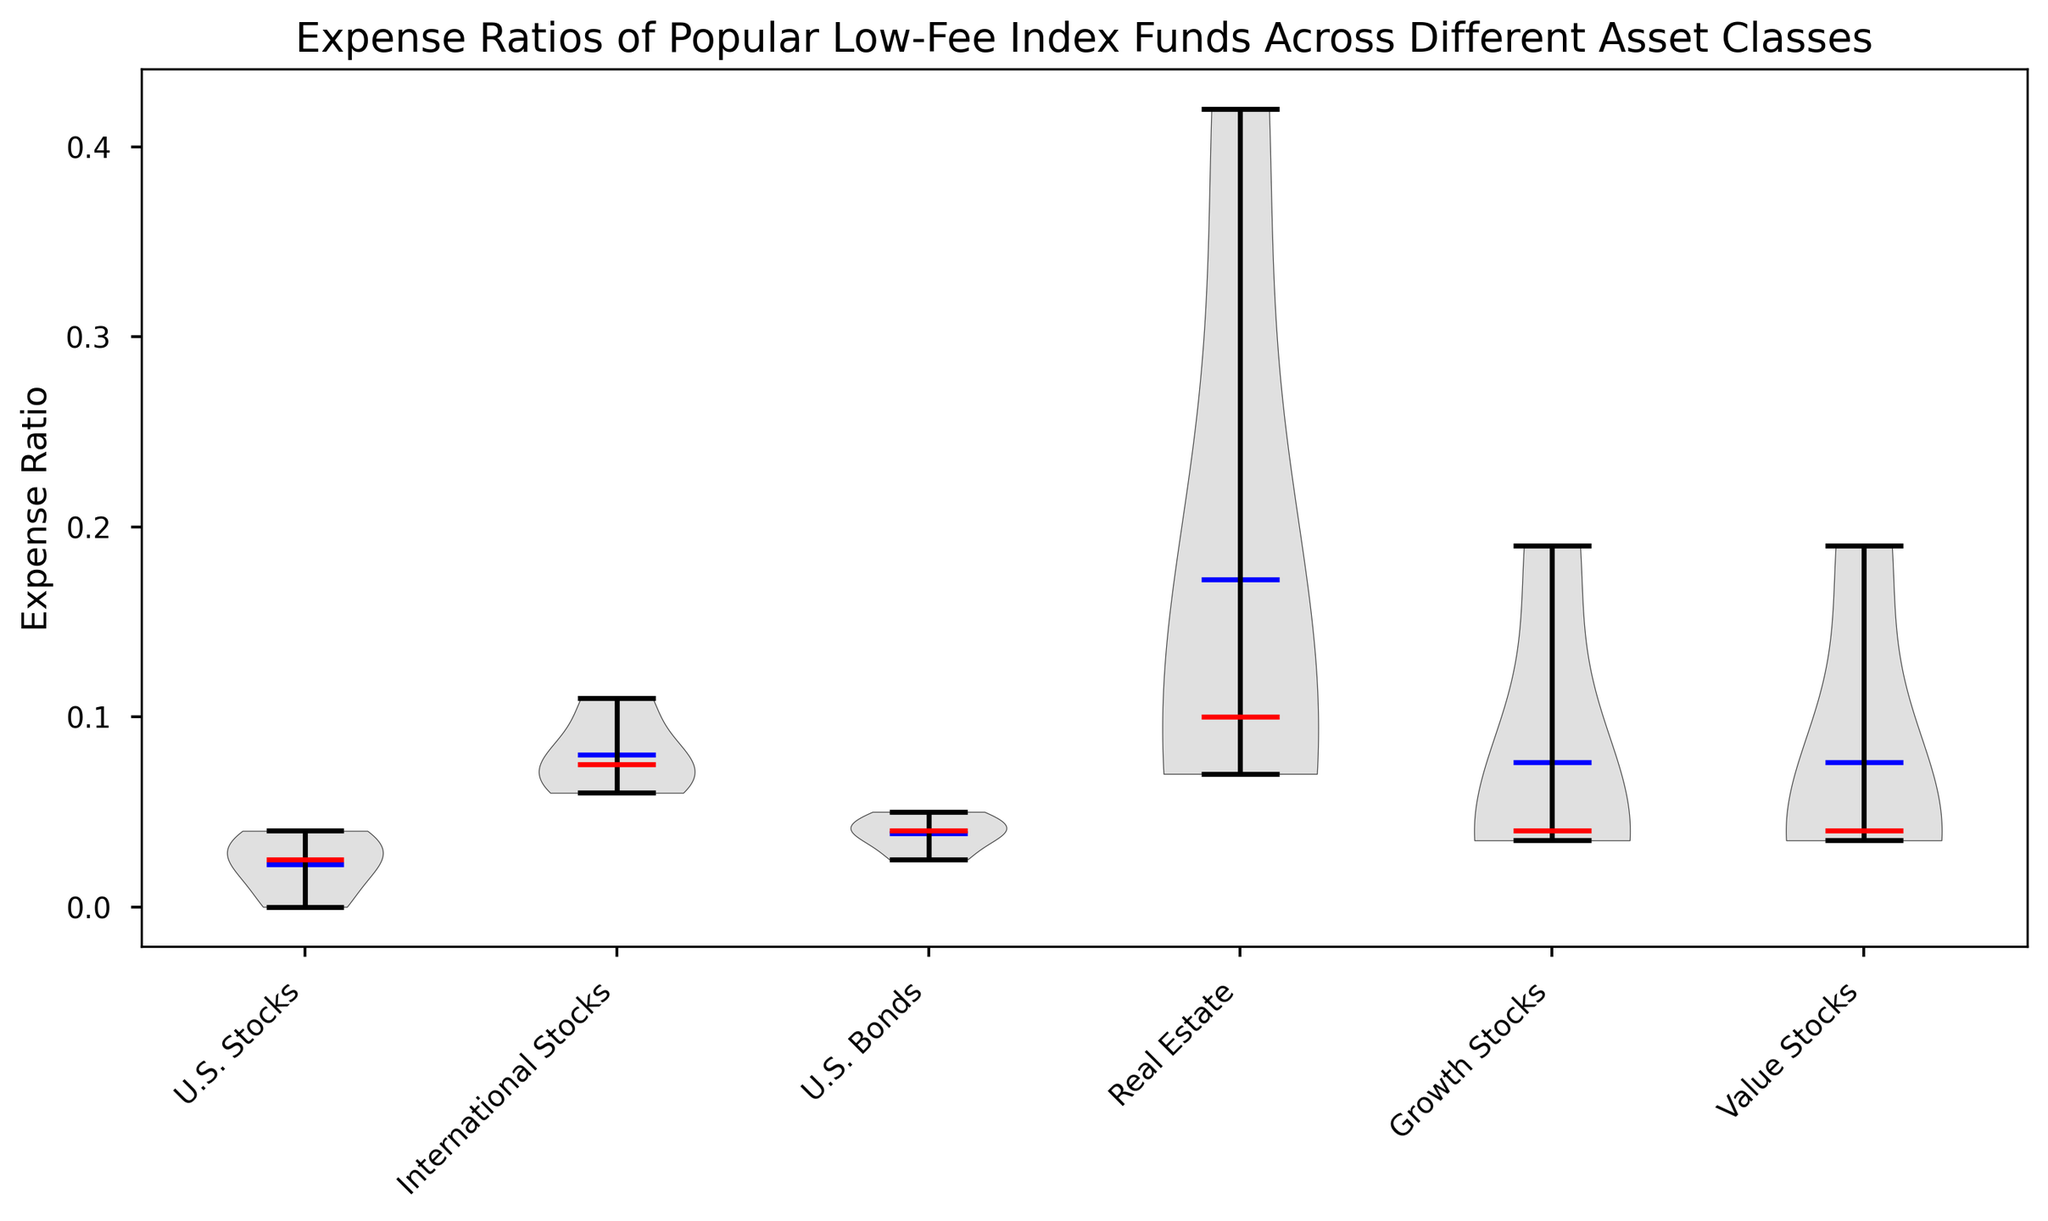What is the range of Expense Ratios for U.S. Stocks funds? The range of Expense Ratios for U.S. Stocks funds can be determined by observing the highest and lowest points of the U.S. Stocks section on the violin plot. The minimum value is 0.00 (Fidelity ZERO Total Market Index Fund) and the maximum value is 0.04 (Vanguard Total Stock Market Index Fund).
Answer: 0.00 to 0.04 Which asset class has the highest median Expense Ratio? The median Expense Ratio is indicated by the red line inside each violin. The Real Estate asset class has the highest median Expense Ratio among all the classes shown.
Answer: Real Estate Which asset class has the most variation in Expense Ratios? Variation can be observed by the width and spread of the violins. The Real Estate asset class shows the most variation, as its violin is the widest and has the broadest range of values.
Answer: Real Estate What are the mean Expense Ratios for U.S. Bonds and International Stocks? The mean Expense Ratio is indicated by the blue line within the violins. By checking the plot, the mean for U.S. Bonds is around 0.0375, and for International Stocks, it is around 0.08.
Answer: Approximately 0.0375 for U.S. Bonds and 0.08 for International Stocks Compare and contrast the median Expense Ratios for Growth Stocks and Value Stocks. The red lines indicate the median values. Both Growth Stocks and Value Stocks have similar median Expense Ratios, which are approximately 0.04 each.
Answer: Both are around 0.04 Which funds have an Expense Ratio exactly equal to the mean value of Expense Ratios in Real Estate? The violin plot shows the mean (blue line) for Real Estate, which is approximately 0.1675. The iShares U.S. Real Estate ETF with a 0.42 does not match. In this case, no single fund appears to have an Expense Ratio of exactly 0.1675 from the data points.
Answer: None How does the range of Expense Ratios in U.S. Bonds compare to that of Growth Stocks? To compare, observe the ranges for both asset classes in their respective violins. U.S. Bonds range from 0.025 to 0.05, while Growth Stocks range from 0.035 to 0.19. U.S. Bonds have a narrower range.
Answer: U.S. Bonds (narrower), Growth Stocks (wider) Which asset class has the smallest mean Expense Ratio and what is that value? The smallest mean Expense Ratio is indicated by the blue lines. The U.S. Stocks asset class has the smallest mean Expense Ratio, which is close to 0.0225.
Answer: U.S. Stocks, approximately 0.0225 Is there any asset class where all funds have an Expense Ratio below 0.10? By examining the violins, it is clear that all funds in U.S. Stocks, U.S. Bonds, and Value Stocks have an Expense Ratio below 0.10.
Answer: Yes, U.S. Stocks, U.S. Bonds, and Value Stocks 